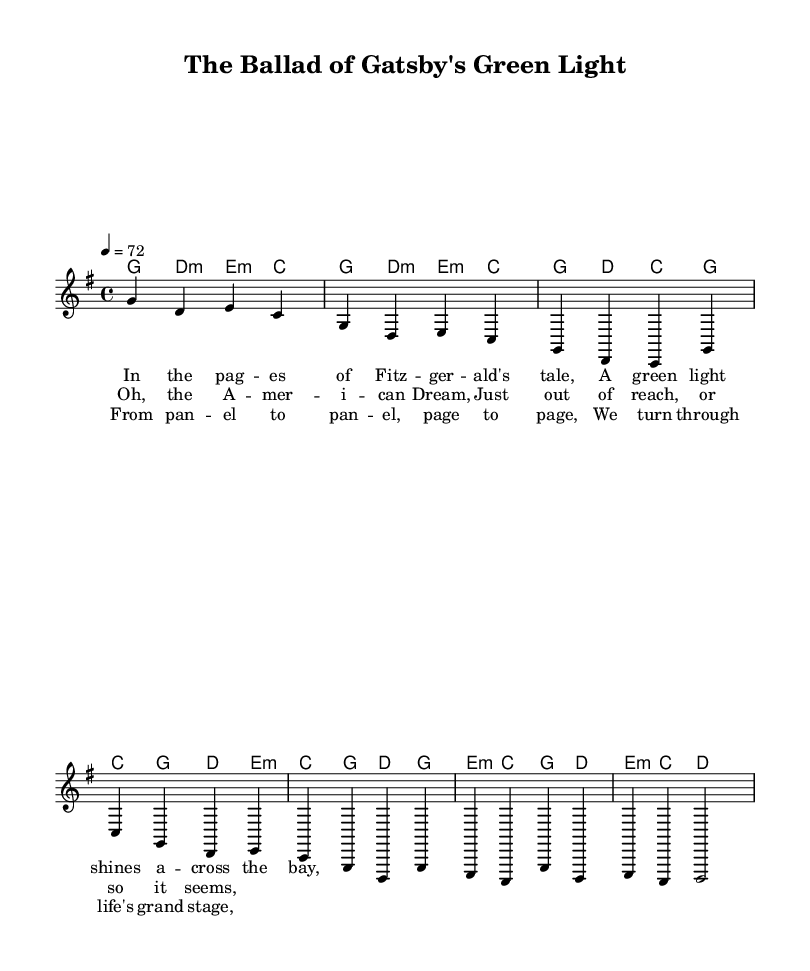What is the key signature of this music? The key signature is G major, which has one sharp (F#). This can be inferred from the global section where it specifies \key g \major.
Answer: G major What is the time signature of this music? The time signature is 4/4, as stated in the global section of the code where it specifies \time 4/4. This indicates that there are four beats per measure and the quarter note receives one beat.
Answer: 4/4 What is the tempo marking for this piece? The tempo marking is 72 beats per minute, indicated in the global section with \tempo 4 = 72. This means the music should be played at a moderate pace, with each quarter note receiving one beat at that speed.
Answer: 72 How many verses are present in the song? There are two verses in the song, as indicated by the portions labeled verse in the code, specifically, the lines defined under \lyricmode tagged with verseOne and the repeating structure after the chorus.
Answer: Two What theme does the chorus of the song primarily address? The chorus addresses the theme of the American Dream, as it states, "Oh, the American Dream, Just out of reach, or so it seems." This signifies a pursuit that remains elusive, a key element in many country ballads.
Answer: American Dream How does the bridge contribute to the overall storytelling of the ballad? The bridge introduces a reflective tone, with lines like "From panel to panel, page to page, We turn through life's grand stage." This emphasizes the journey through life and the narrative structure in literature, connecting it to the song's illustrative storytelling element.
Answer: Reflective tone What is the main chord used in the introduction? The main chord used in the introduction is G major, as indicated in the harmonies section where it is the first chord mentioned in the sequence. This establishes the tonal center of the piece right from the beginning.
Answer: G major 